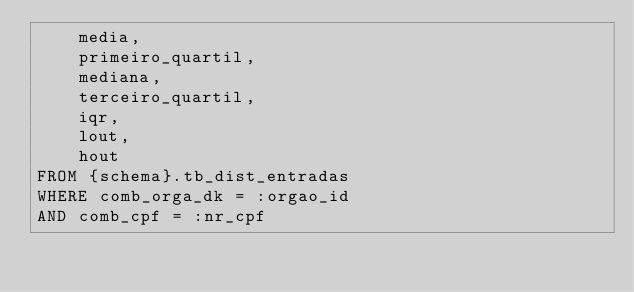<code> <loc_0><loc_0><loc_500><loc_500><_SQL_>    media,
    primeiro_quartil,
    mediana,
    terceiro_quartil,
    iqr,
    lout,
    hout
FROM {schema}.tb_dist_entradas
WHERE comb_orga_dk = :orgao_id
AND comb_cpf = :nr_cpf</code> 